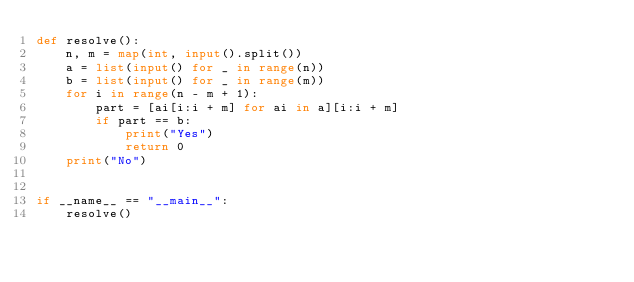<code> <loc_0><loc_0><loc_500><loc_500><_Python_>def resolve():
    n, m = map(int, input().split())
    a = list(input() for _ in range(n))
    b = list(input() for _ in range(m))
    for i in range(n - m + 1):
        part = [ai[i:i + m] for ai in a][i:i + m]
        if part == b:
            print("Yes")
            return 0
    print("No")


if __name__ == "__main__":
    resolve()
</code> 